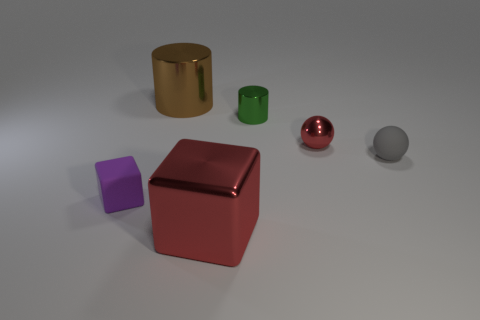Add 2 small rubber things. How many objects exist? 8 Subtract all blocks. How many objects are left? 4 Subtract 0 green balls. How many objects are left? 6 Subtract all cyan objects. Subtract all tiny purple rubber cubes. How many objects are left? 5 Add 3 shiny things. How many shiny things are left? 7 Add 3 red matte objects. How many red matte objects exist? 3 